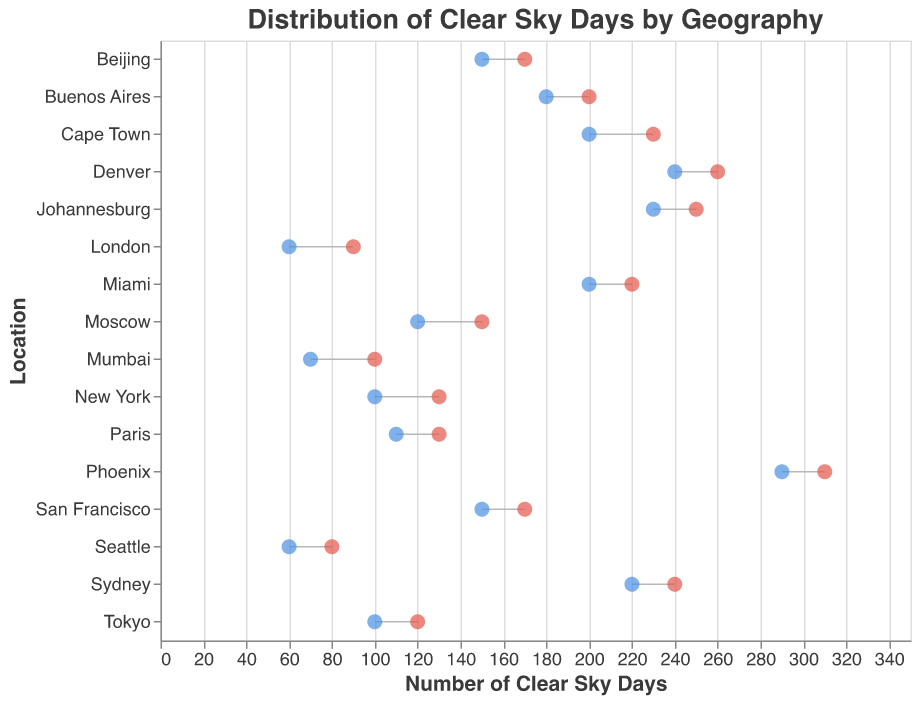What is the title of the plot? The title is at the top of the plot and reads "Distribution of Clear Sky Days by Geography".
Answer: Distribution of Clear Sky Days by Geography How many locations have a range for clear sky days that starts below 100? Look at the minimum values for the ranges: Seattle (60), London (60), Mumbai (70), New York (100), and Tokyo (100). Only Seattle, London, and Mumbai start below 100.
Answer: 3 What is the range of clear sky days for Denver? Denver's minimum and maximum clear sky days are marked with two points connected by a line. The numbers are 240 to 260.
Answer: 240-260 Which location has the highest maximum number of clear sky days? Scan the maximum clear sky days values across all locations. Phoenix has the highest maximum value with 310 days.
Answer: Phoenix How many locations have a maximum number of clear sky days above 200? The locations with maximum values above 200 are: Miami, Denver, Phoenix, Sydney, Cape Town, and Johannesburg. Count these locations.
Answer: 6 What is the difference in maximum clear sky days between Miami and Buenos Aires? Find the maximum clear sky days for Miami (220) and Buenos Aires (200), and compute the difference: 220 - 200 = 20.
Answer: 20 Which location has the smallest range of clear sky days? Calculate the range for each location by subtracting the minimum from the maximum. London has the smallest range: 90 - 60 = 30.
Answer: London Between which two locations is the difference in their minimum clear sky days the greatest? Check all the minimum values and compute the differences, for example, Phoenix (290) and Seattle (60). 290 - 60 = 230 is the greatest difference.
Answer: Phoenix and Seattle What is the average minimum number of clear sky days across all locations? Add the minimum values and divide by the number of locations. (150 + 60 + 200 + 240 + 290 + 100 + 60 + 220 + 100 + 200 + 120 + 180 + 150 + 70 + 230 + 110) / 16 = 1860 / 16 = 116.25.
Answer: 116.25 Which locations have a maximum of clear sky days equal to the minimum of Johannesburg? Johannesburg's minimum is 230. Search for maximums equal to 230: Cape Town has a maximum value of 230.
Answer: Cape Town 